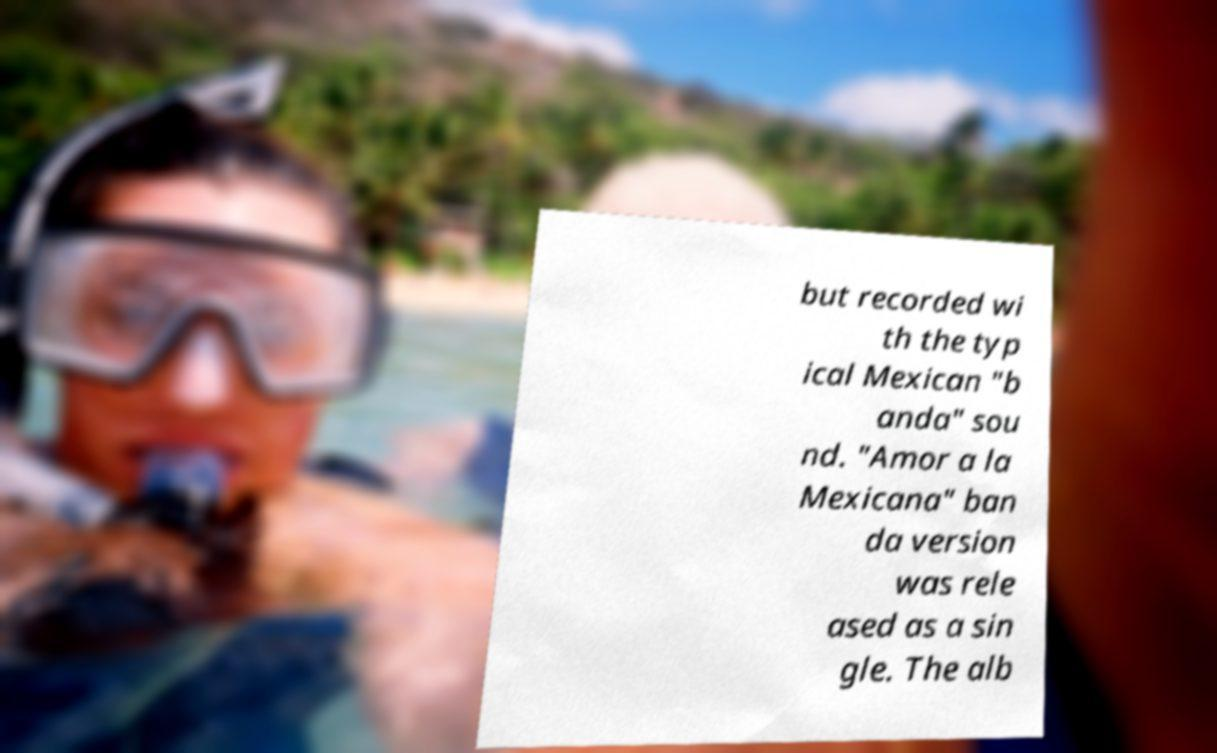Please identify and transcribe the text found in this image. but recorded wi th the typ ical Mexican "b anda" sou nd. "Amor a la Mexicana" ban da version was rele ased as a sin gle. The alb 